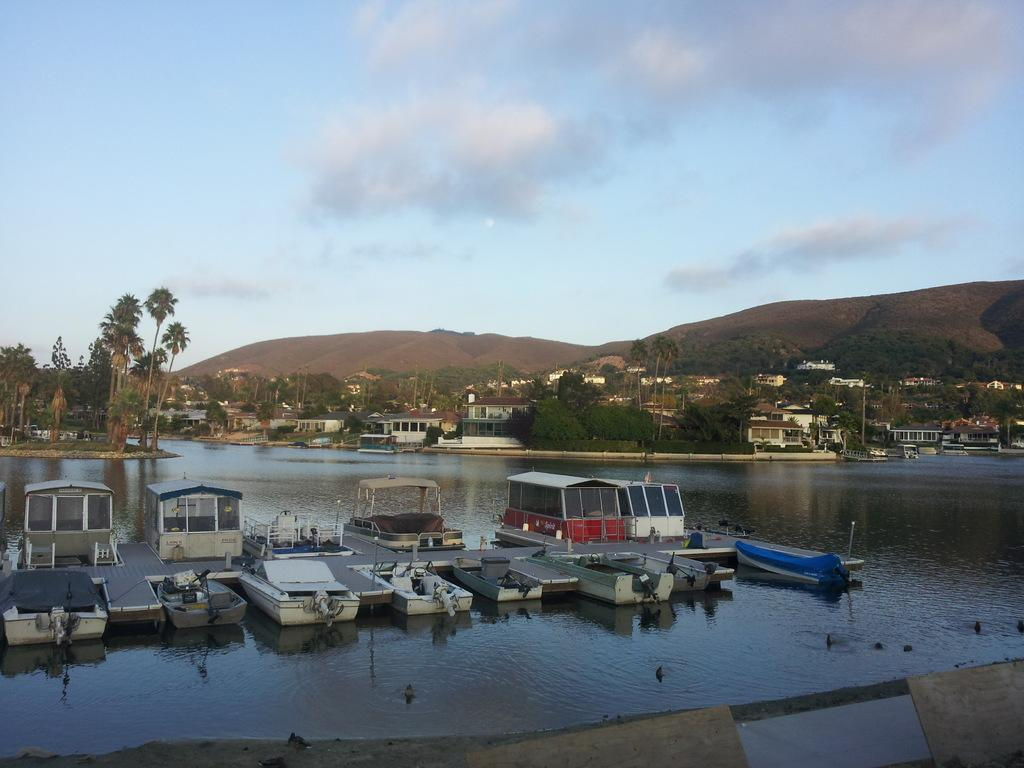What is on the water in the image? There are boats on the water in the image. What type of natural environment can be seen in the image? There are trees visible in the image. What type of structures are present in the image? There are houses in the image. What else can be seen in the image besides the houses? There are poles in the image. What is the background of the image? The sky with clouds is visible in the background of the image. Can you describe the landscape in the image? The image features a body of water with boats, trees, houses, poles, a mountain, and a sky with clouds in the background. How does the toad cause an earthquake in the image? There is no toad or earthquake present in the image. What command is given to the boats to stop in the image? There is no command given to the boats in the image; they are stationary on the water. 